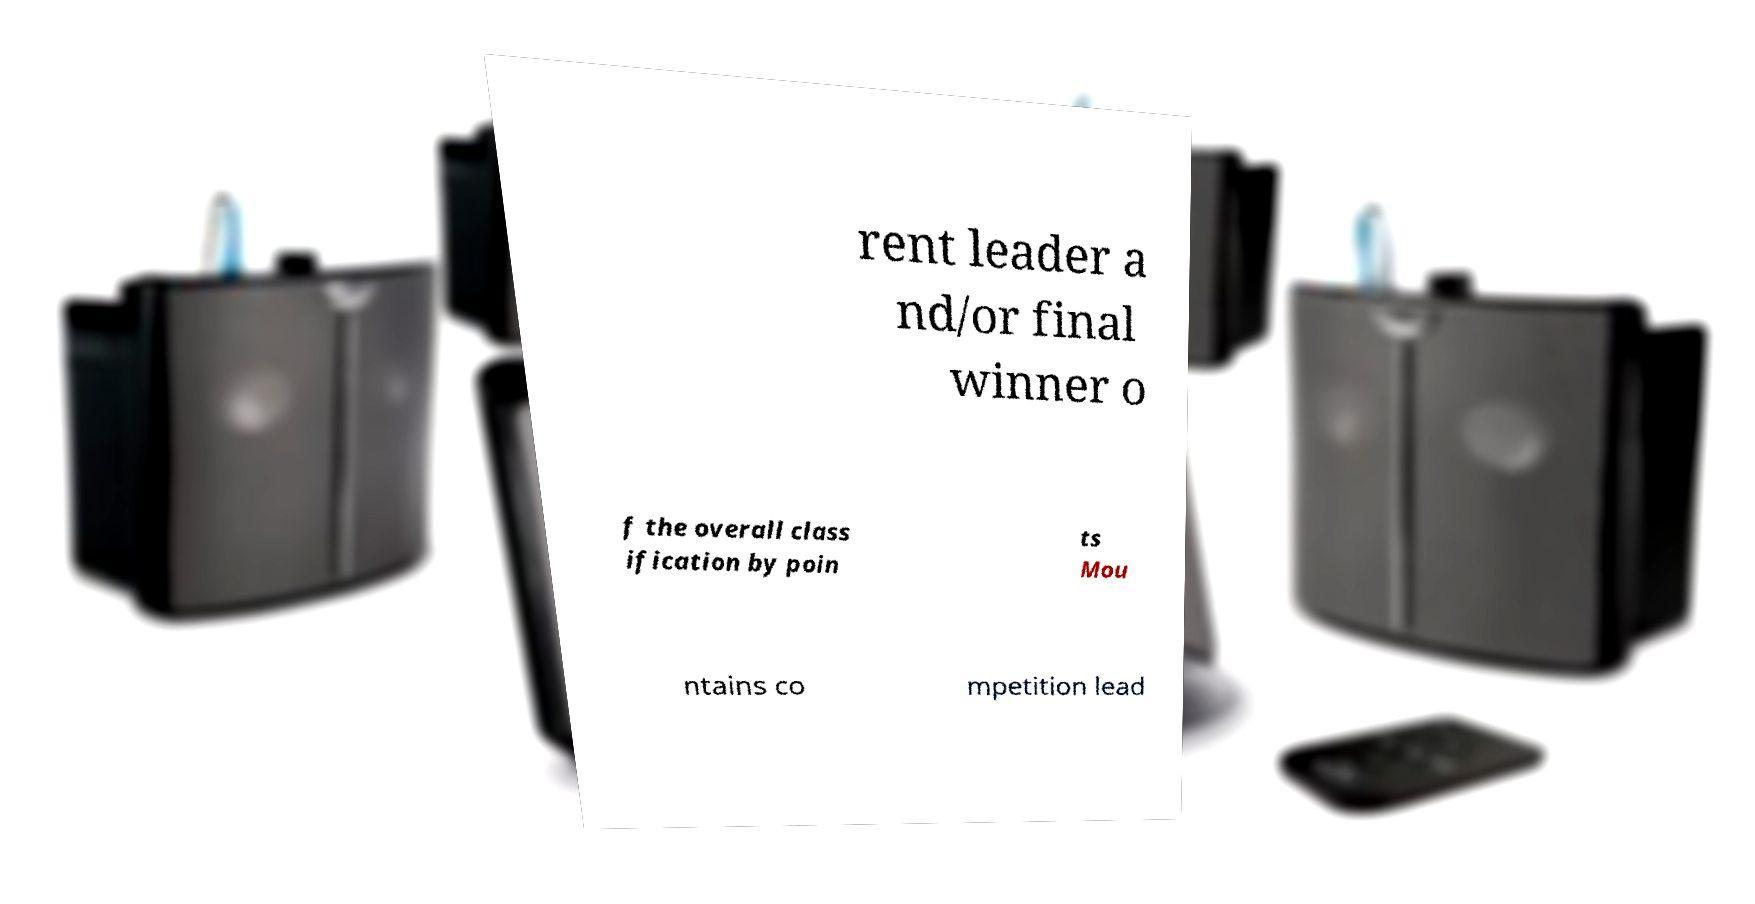What messages or text are displayed in this image? I need them in a readable, typed format. rent leader a nd/or final winner o f the overall class ification by poin ts Mou ntains co mpetition lead 